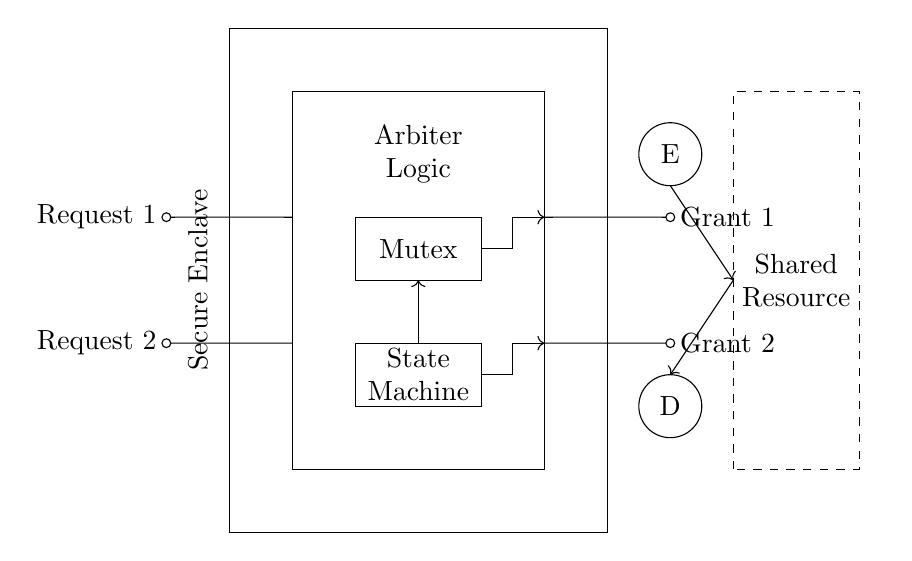What is the role of the "Arbiter Logic"? The Arbiter Logic is responsible for deciding which request, either Request 1 or Request 2, gets access to the Shared Resource. It ensures that only one request can be granted at any one time, preventing conflict and ensuring orderly access.
Answer: Decides access What type of components are represented in the circuit? The components in the circuit include a Mutex, a State Machine, a Secure Enclave, and two encryption/decryption units (E and D). These elements work together to manage access control and secure data communication.
Answer: Mutex, State Machine, Secure Enclave, E, D How many requests can the arbiter handle simultaneously? The arbiter can only handle one request at a time, which is indicated by the two separate request input lines and the corresponding grant outputs. This setup reflects the basic principle of an arbiter that avoids simultaneous resource access.
Answer: One request What does "Grant 1" signify? "Grant 1" signifies that the Arbiter Logic has granted permission for Request 1 to access the Shared Resource, allowing it to proceed while Request 2 is denied access at that moment.
Answer: Access granted to Request 1 What does the dashed rectangle represent in the circuit? The dashed rectangle represents the Shared Resource, indicating the component that both requests are attempting to access and that requires management by the arbiter to prevent conflicts.
Answer: Shared Resource Describe the function of the Secure Enclave in the circuit. The Secure Enclave's function is to protect sensitive information and manage encryption/decryption processes for the requests being granted access to the Shared Resource, ensuring that data remains secure during transmission.
Answer: Protects sensitive data What are the main outputs of the arbiter? The main outputs of the arbiter are "Grant 1" and "Grant 2," which indicate which of the two requests is permitted to access the Shared Resource at any given time.
Answer: Grant 1 and Grant 2 